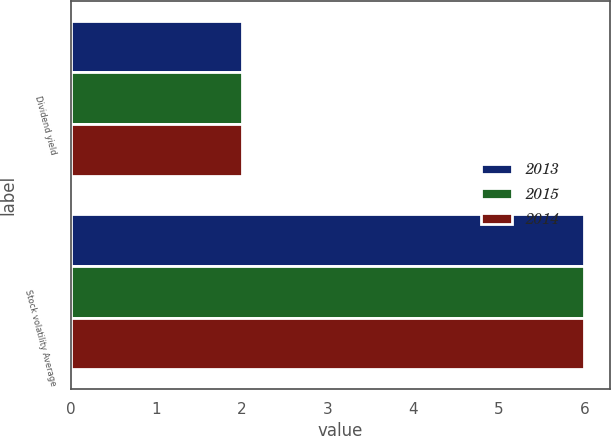<chart> <loc_0><loc_0><loc_500><loc_500><stacked_bar_chart><ecel><fcel>Dividend yield<fcel>Stock volatility Average<nl><fcel>2013<fcel>2<fcel>6<nl><fcel>2015<fcel>2<fcel>6<nl><fcel>2014<fcel>2<fcel>6<nl></chart> 